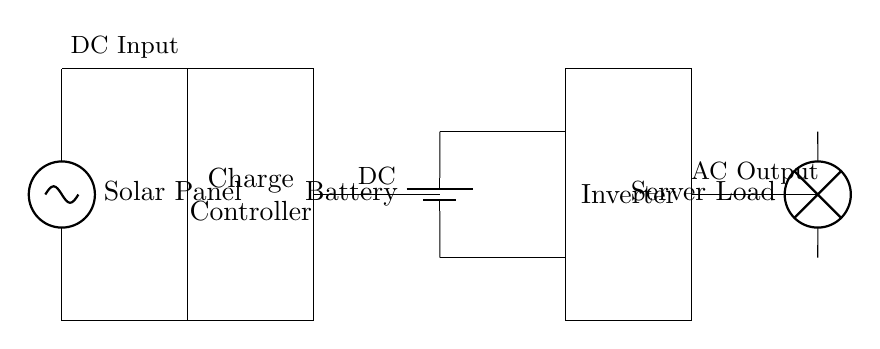What is the main component that generates electricity in this circuit? The main component that generates electricity is the solar panel, identified at the left of the circuit diagram. It converts sunlight into electrical energy.
Answer: Solar Panel What is the purpose of the charge controller in this system? The charge controller manages the charging of the battery from the solar panel, preventing overcharging and ensuring efficient usage of the solar energy generated.
Answer: Charge Controller What type of load is being powered by this system? The load being powered is a server load, which typically requires a stable power supply to function properly. This is indicated by the lamp symbol representing the server load at the end of the circuit diagram.
Answer: Server Load How many components are connected in series between the solar panel and the battery? There are three components connected in series: the solar panel, the charge controller, and the battery, overall facilitating the flow of electricity from generation to storage.
Answer: Three What type of output is provided to the server load? The server load receives an alternating current output from the inverter, which converts the direct current from the battery to alternating current suitable for the load.
Answer: AC Output What is the function of the inverter in this circuit? The inverter converts the direct current stored in the battery into alternating current suitable for powering devices such as servers. It is essential for ensuring compatibility with standard electrical equipment.
Answer: Convert DC to AC What could happen if the battery is overcharged? Overcharging the battery can lead to electrical fires, battery damage, or reduced lifespan due to overheating or leakage. Charge controllers are crucial in preventing this scenario.
Answer: Damage to Battery 